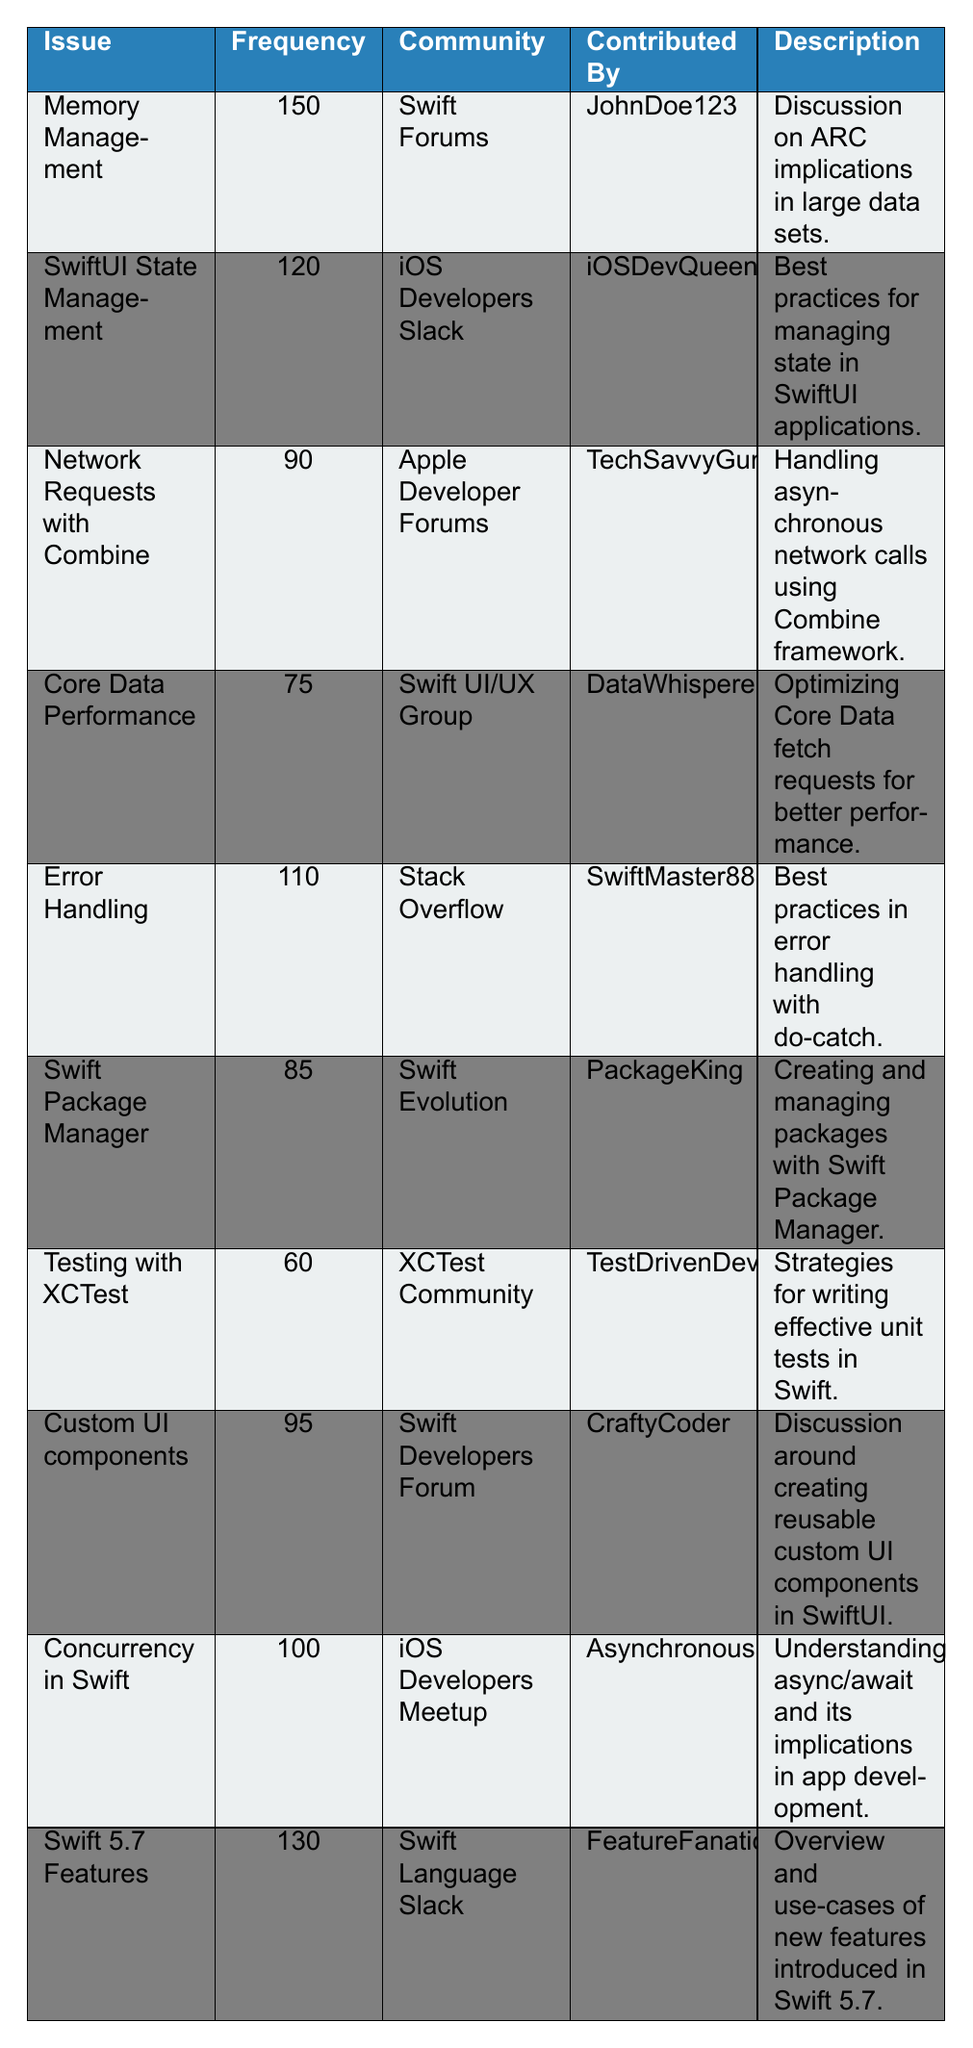What is the most frequently discussed issue in the table? The table shows the frequency of various issues. By examining the "Frequency" column, "Memory Management" has the highest frequency at 150.
Answer: Memory Management Which community discussed "Error Handling"? Looking at the "Community" column for the "Error Handling" issue, it is associated with "Stack Overflow."
Answer: Stack Overflow How many issues have a frequency greater than 100? By counting the frequency values that are greater than 100, we find "Memory Management" (150), "Swift 5.7 Features" (130), "SwiftUI State Management" (120), and "Error Handling" (110). This gives us four issues.
Answer: 4 What is the combined frequency of issues related to Swift Package Manager and Testing with XCTest? The frequency for "Swift Package Manager" is 85 and for "Testing with XCTest" it is 60. Adding these gives 85 + 60 = 145.
Answer: 145 True or False: The issue "Concurrency in Swift" was contributed by "FeatureFanatic." By checking the "Contributed By" column for "Concurrency in Swift," it is listed as being contributed by "AsynchronousHero," making the statement false.
Answer: False What is the average frequency of issues contributed by the "Swift Forums"? The only issue from "Swift Forums" is "Memory Management," with a frequency of 150. The average is thus 150/1 = 150.
Answer: 150 Which issue is associated with the least frequency, and what is its frequency? By examining the frequency values, "Testing with XCTest" has the least frequency at 60.
Answer: Testing with XCTest, frequency 60 What is the difference in frequency between "Swift 5.7 Features" and "Network Requests with Combine"? The frequency for "Swift 5.7 Features" is 130 and for "Network Requests with Combine" it is 90. The difference is 130 - 90 = 40.
Answer: 40 Identify the community with the second highest frequency issue. The highest frequency is from "Swift Forums" (150) and the second highest is from "Swift Language Slack" with a frequency of 130.
Answer: Swift Language Slack Which issue focuses on creating reusable custom UI components? The "Description" for "Custom UI components" indicates it focuses on creating reusable custom UI components in SwiftUI.
Answer: Custom UI components 